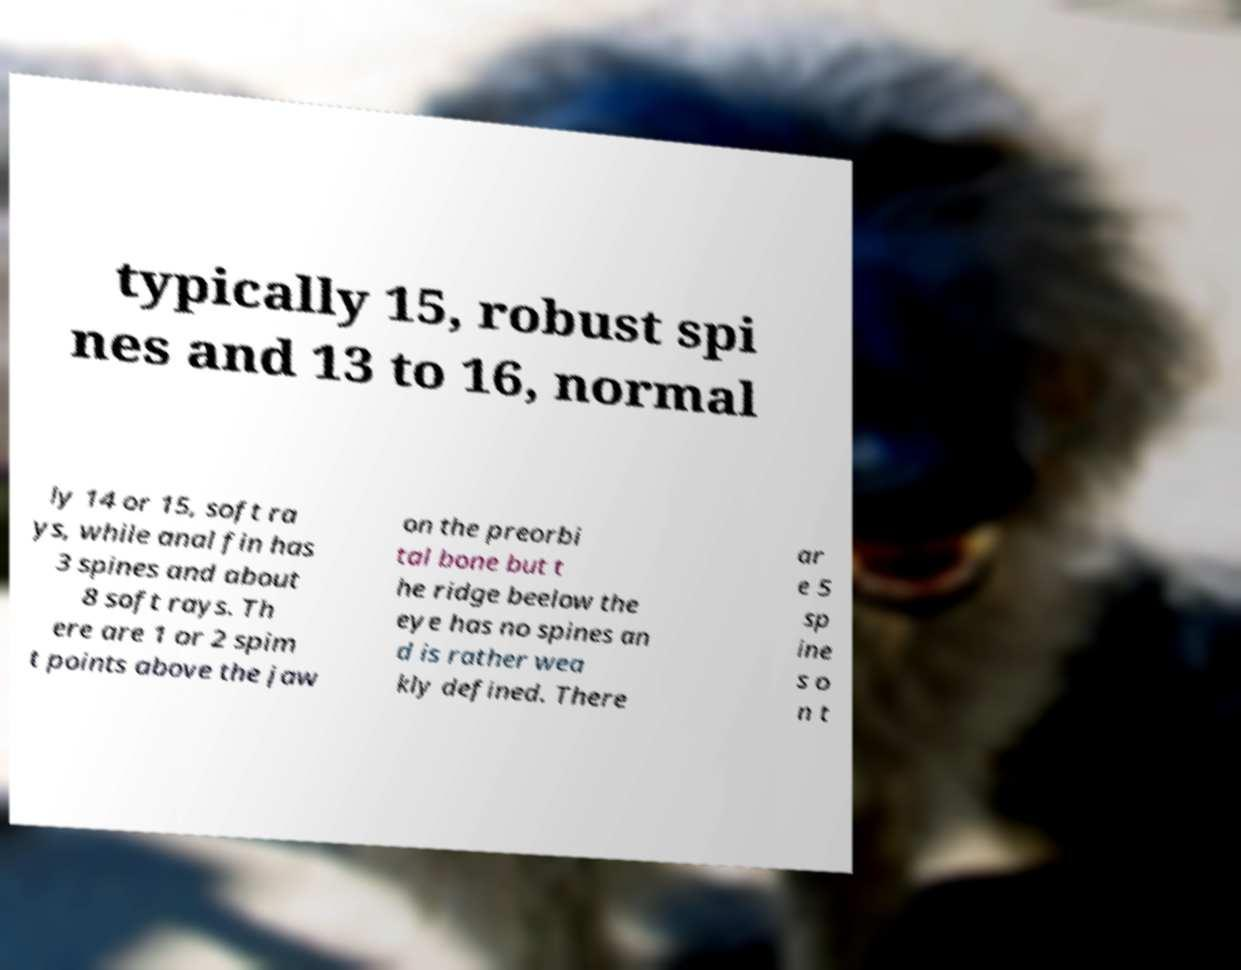Please identify and transcribe the text found in this image. typically 15, robust spi nes and 13 to 16, normal ly 14 or 15, soft ra ys, while anal fin has 3 spines and about 8 soft rays. Th ere are 1 or 2 spim t points above the jaw on the preorbi tal bone but t he ridge beelow the eye has no spines an d is rather wea kly defined. There ar e 5 sp ine s o n t 